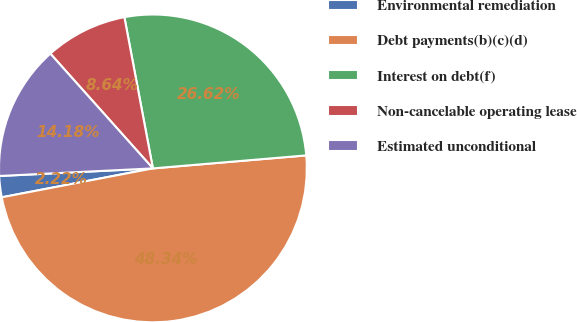<chart> <loc_0><loc_0><loc_500><loc_500><pie_chart><fcel>Environmental remediation<fcel>Debt payments(b)(c)(d)<fcel>Interest on debt(f)<fcel>Non-cancelable operating lease<fcel>Estimated unconditional<nl><fcel>2.22%<fcel>48.34%<fcel>26.62%<fcel>8.64%<fcel>14.18%<nl></chart> 